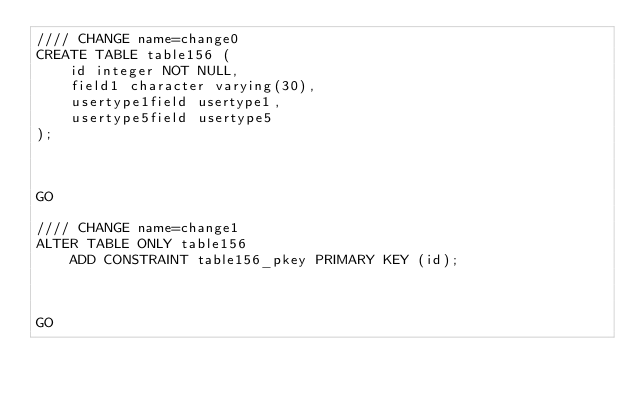<code> <loc_0><loc_0><loc_500><loc_500><_SQL_>//// CHANGE name=change0
CREATE TABLE table156 (
    id integer NOT NULL,
    field1 character varying(30),
    usertype1field usertype1,
    usertype5field usertype5
);



GO

//// CHANGE name=change1
ALTER TABLE ONLY table156
    ADD CONSTRAINT table156_pkey PRIMARY KEY (id);



GO
</code> 